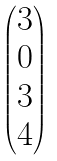<formula> <loc_0><loc_0><loc_500><loc_500>\begin{pmatrix} 3 \\ 0 \\ 3 \\ 4 \end{pmatrix}</formula> 